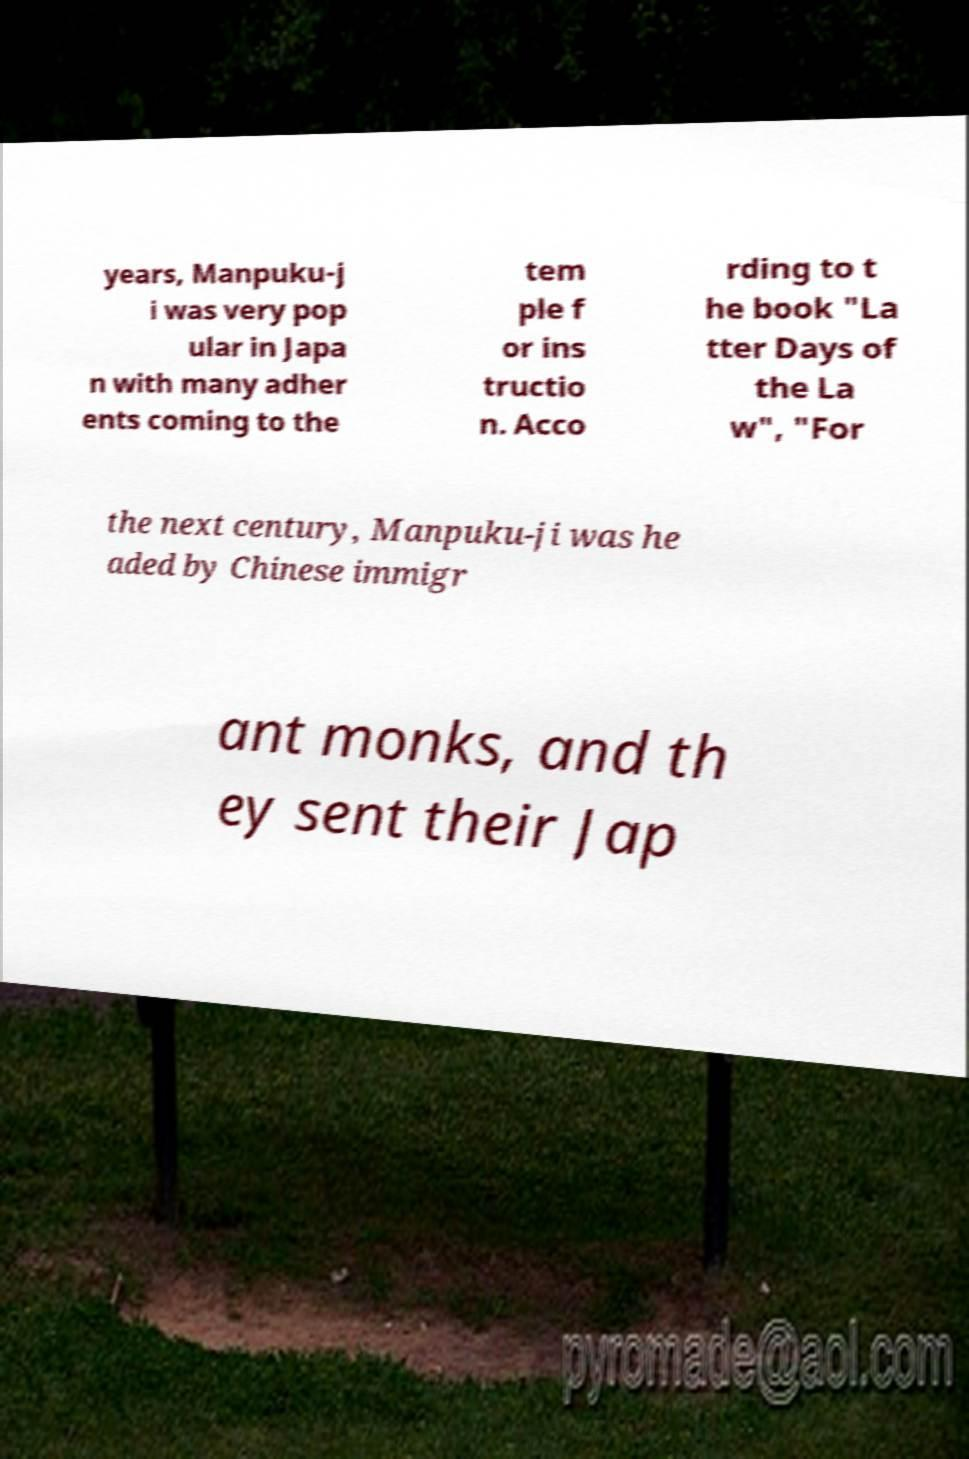What messages or text are displayed in this image? I need them in a readable, typed format. years, Manpuku-j i was very pop ular in Japa n with many adher ents coming to the tem ple f or ins tructio n. Acco rding to t he book "La tter Days of the La w", "For the next century, Manpuku-ji was he aded by Chinese immigr ant monks, and th ey sent their Jap 